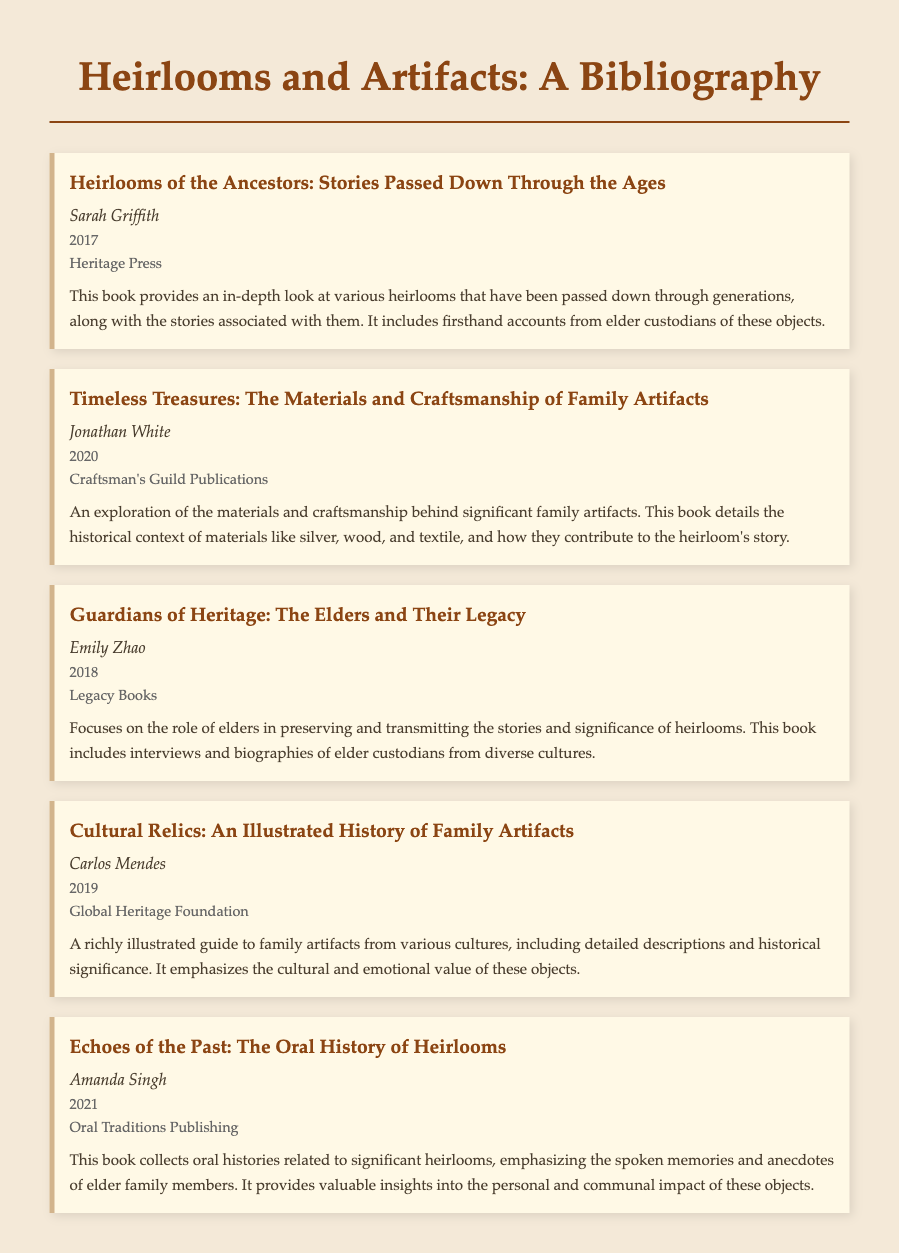what is the title of the first bibliography item? The title of the first bibliography item is provided in bold in the document.
Answer: Heirlooms of the Ancestors: Stories Passed Down Through the Ages who is the author of "Timeless Treasures"? The author's name is listed directly below the title of each bibliography item.
Answer: Jonathan White what year was "Guardians of Heritage" published? The publication year for this item is explicitly noted beneath the author's name.
Answer: 2018 how many bibliography items are included in the document? The total number of items is determined by counting the distinct sections provided.
Answer: 5 which publisher produced "Echoes of the Past"? The publisher is mentioned in the same section as the title and author.
Answer: Oral Traditions Publishing what common theme is explored in "Heirlooms of the Ancestors" and "Guardians of Heritage"? An understanding of thematic similarities requires comparing the key details presented in both items.
Answer: Stories associated with heirlooms which article focuses on the materials used for family artifacts? Identifying the item that discusses materials requires referencing the title and key details.
Answer: Timeless Treasures: The Materials and Craftsmanship of Family Artifacts what type of publication is "Cultural Relics"? The context of the item can be inferred from the content and its significance within the bibliography.
Answer: An illustrated history what focus is shared by both "Echoes of the Past" and "Guardians of Heritage"? This requires assessing how both items discuss the role of elders and storytelling.
Answer: Oral history and elder custodianship 